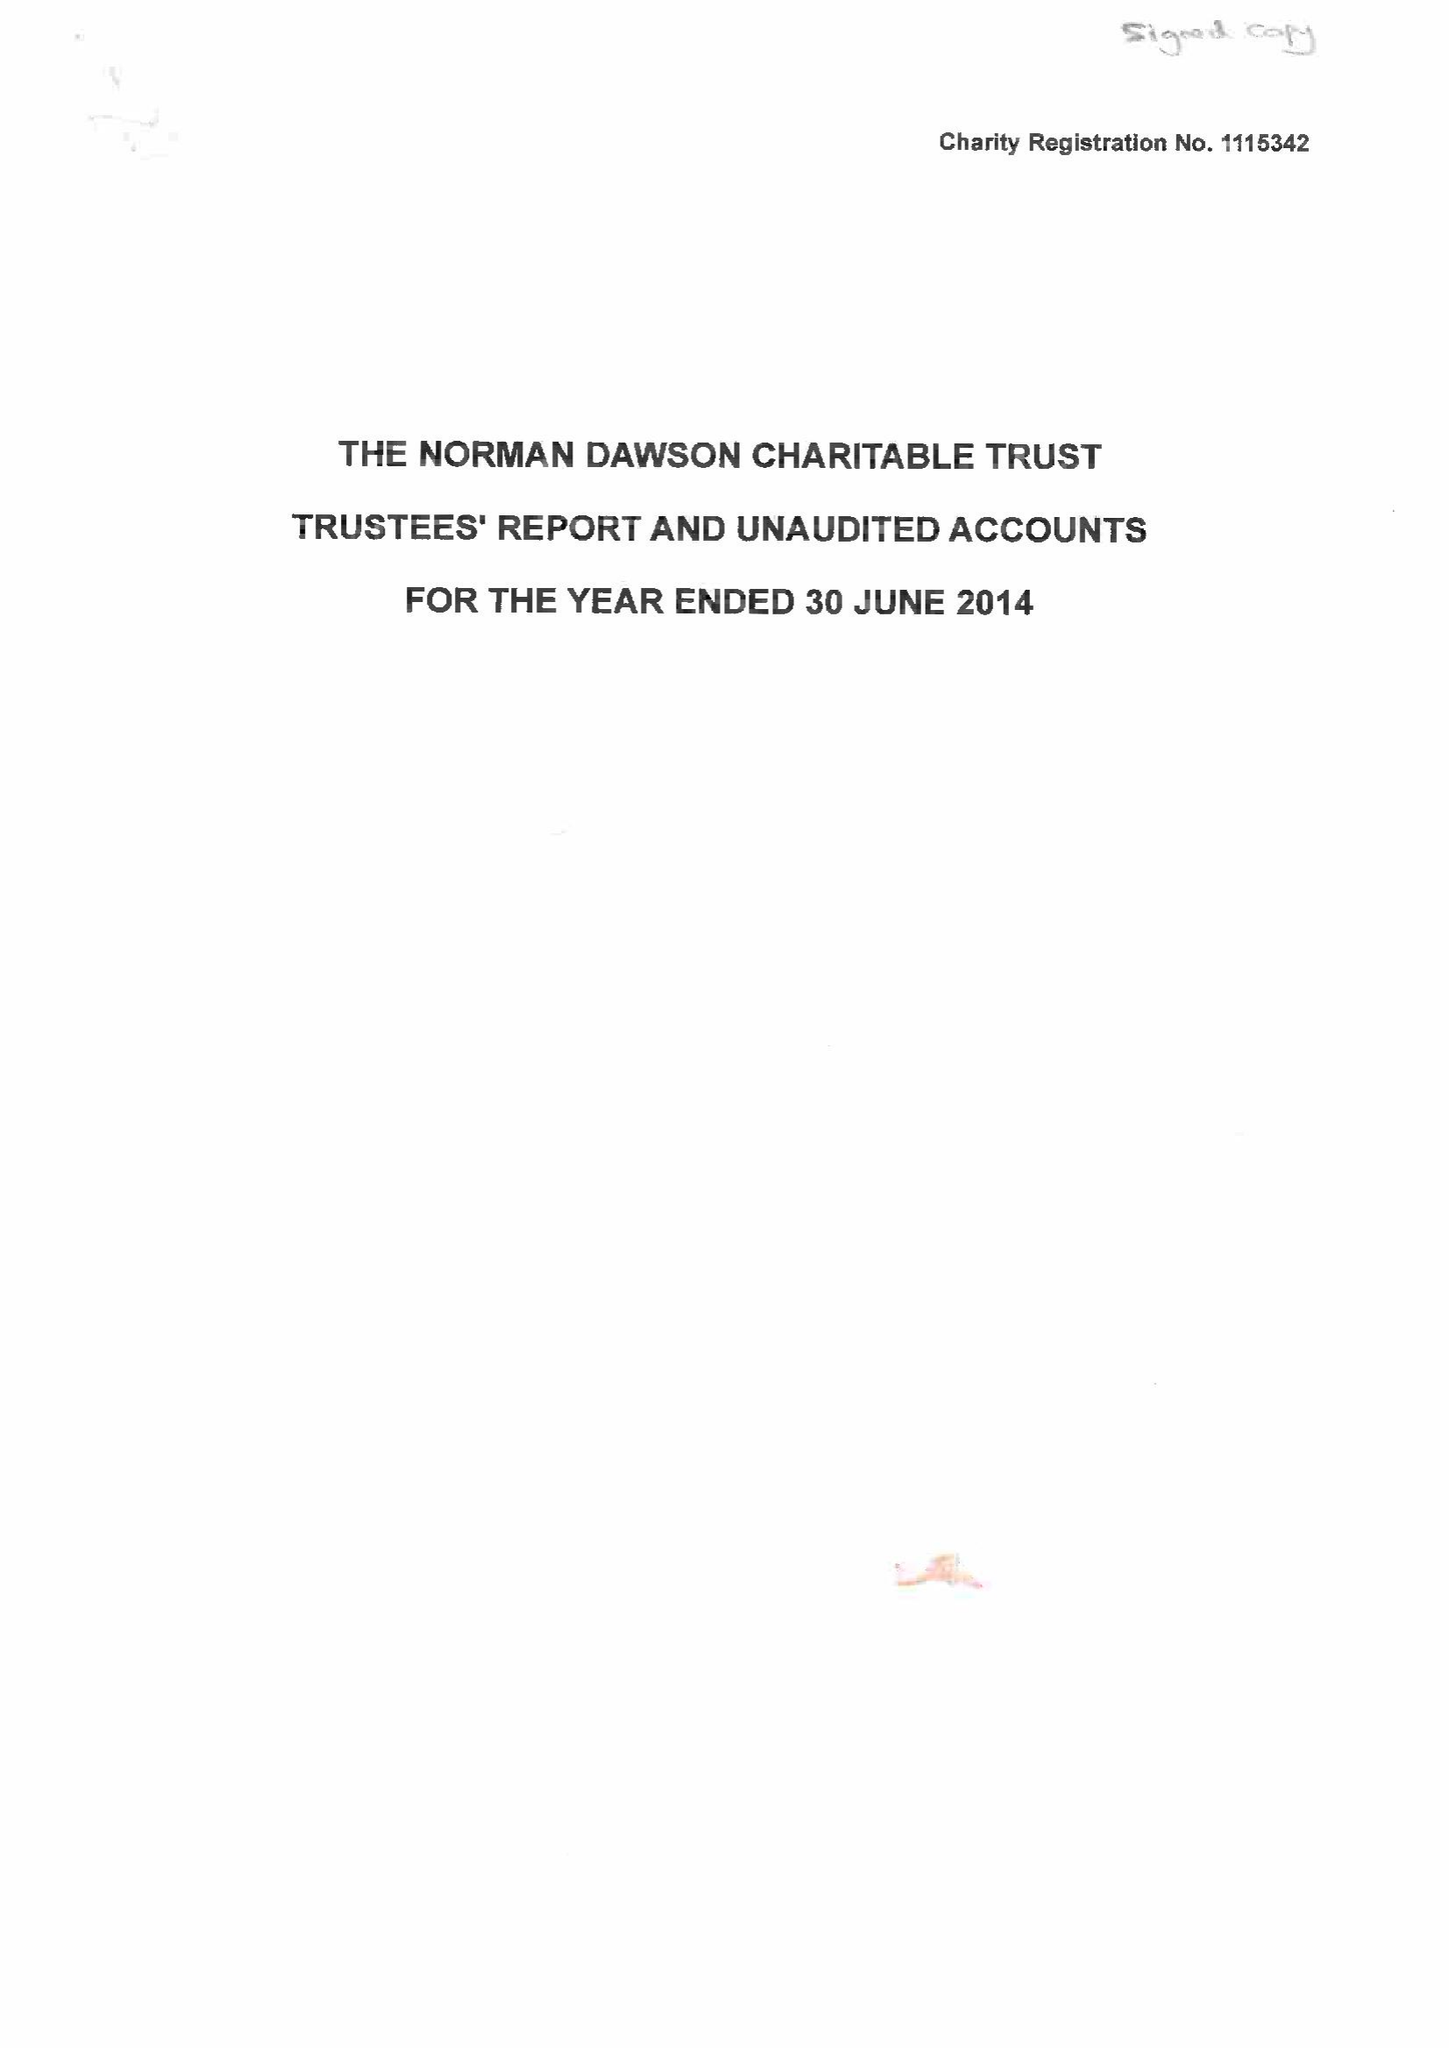What is the value for the report_date?
Answer the question using a single word or phrase. 2014-06-30 